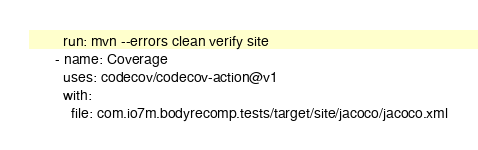<code> <loc_0><loc_0><loc_500><loc_500><_YAML_>        run: mvn --errors clean verify site
      - name: Coverage
        uses: codecov/codecov-action@v1
        with:
          file: com.io7m.bodyrecomp.tests/target/site/jacoco/jacoco.xml
</code> 